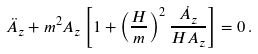Convert formula to latex. <formula><loc_0><loc_0><loc_500><loc_500>\ddot { A } _ { z } + m ^ { 2 } A _ { z } \left [ 1 + \left ( \frac { H } { m } \right ) ^ { 2 } \frac { \dot { A } _ { z } } { H A _ { z } } \right ] = 0 \, .</formula> 